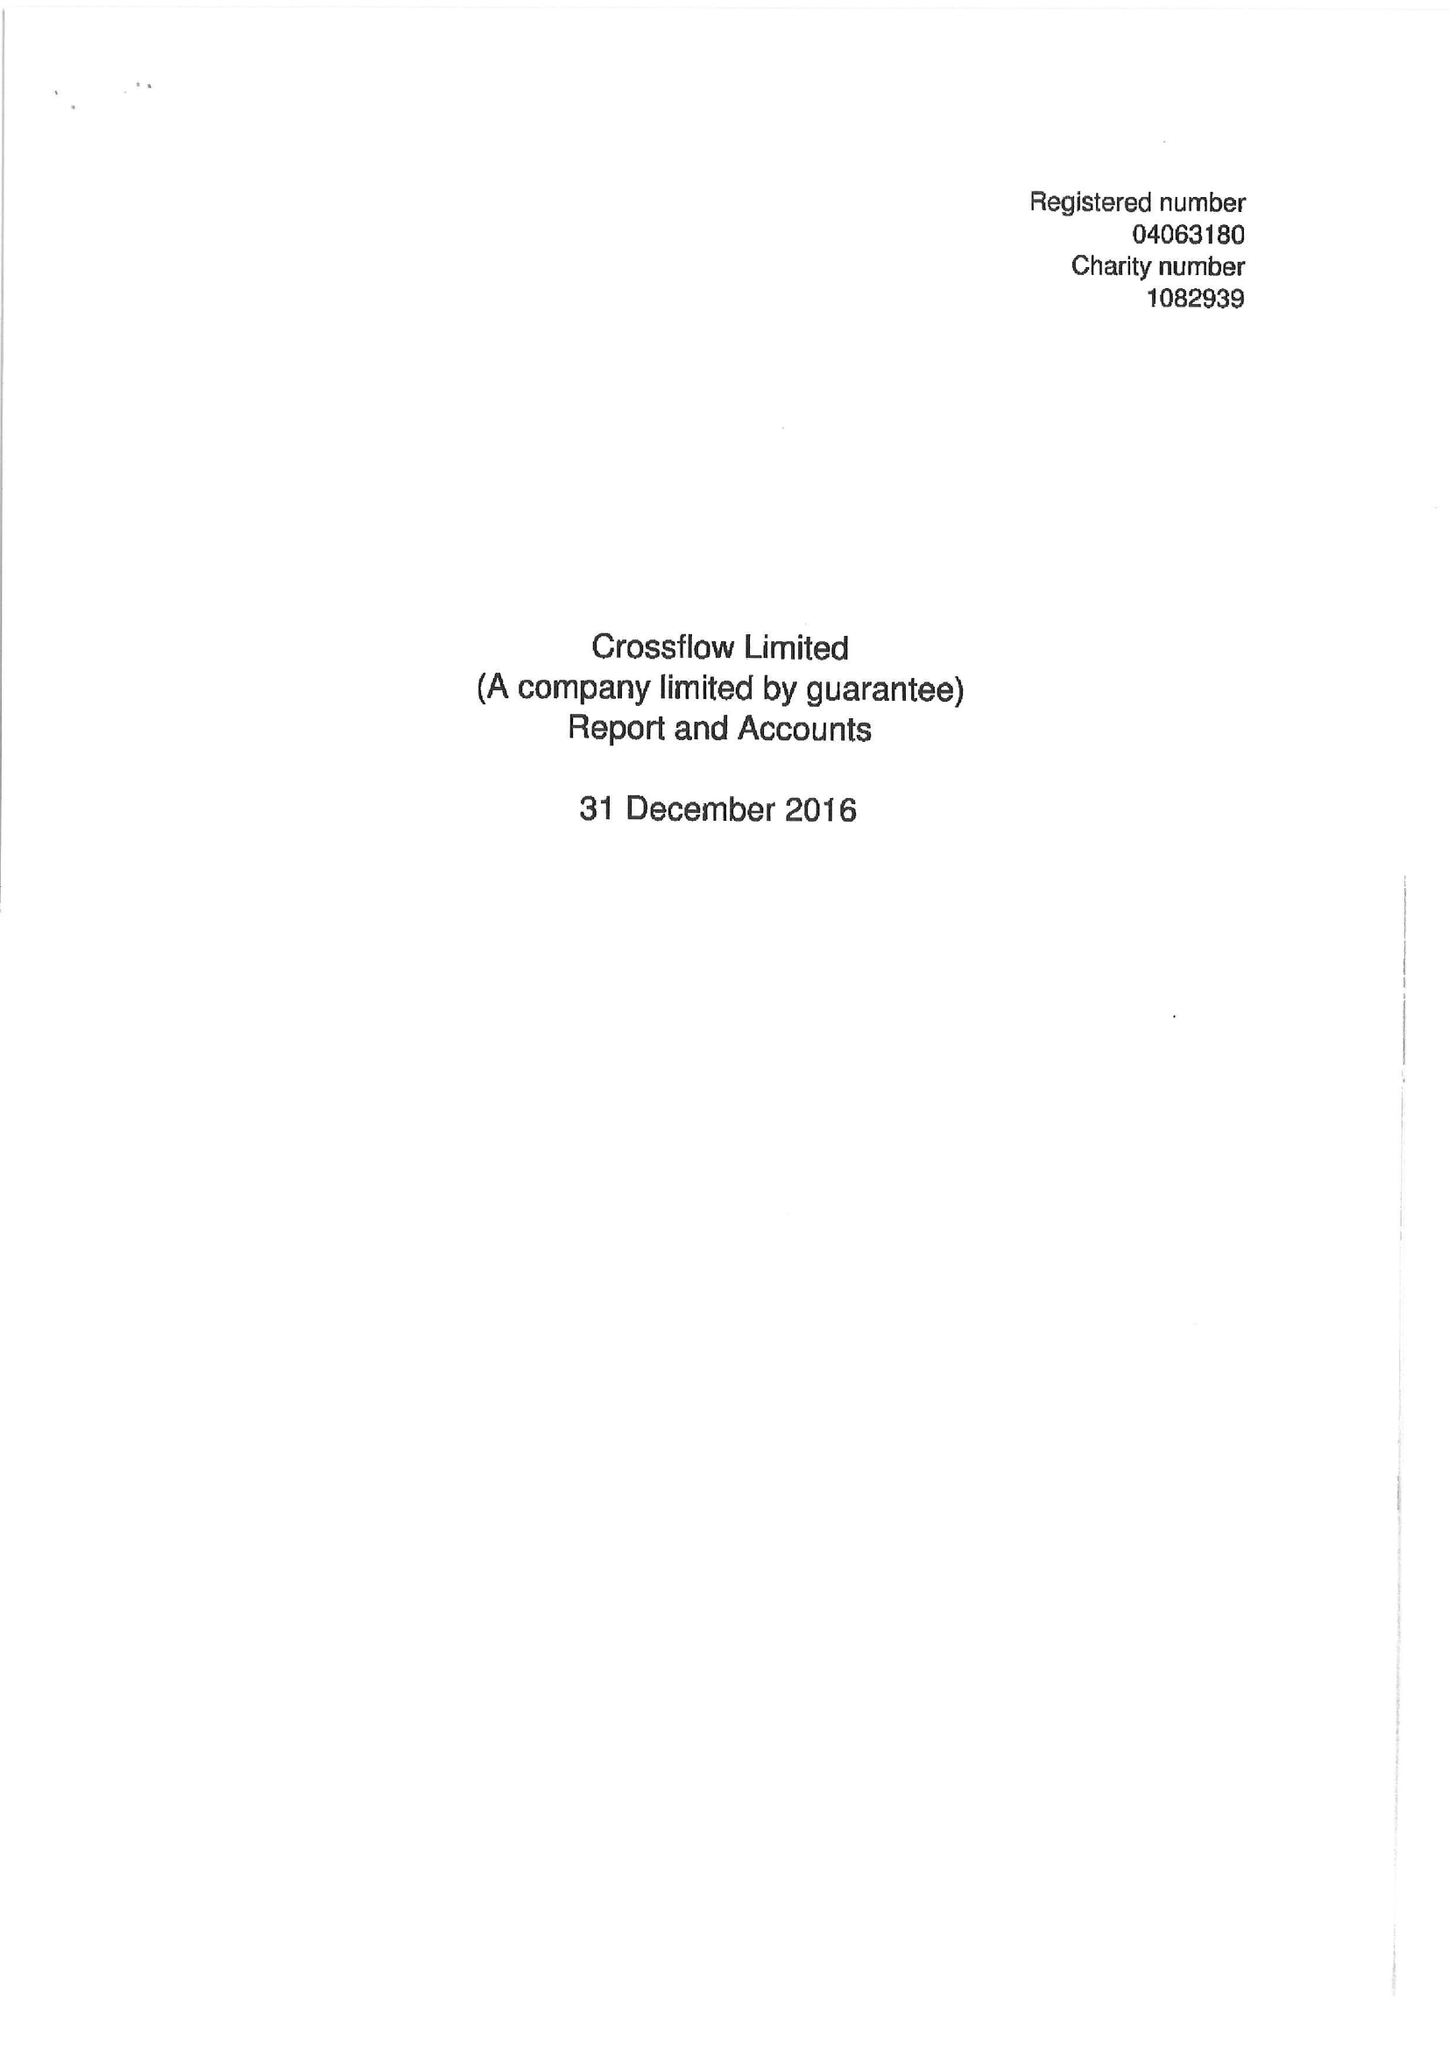What is the value for the report_date?
Answer the question using a single word or phrase. 2016-12-31 